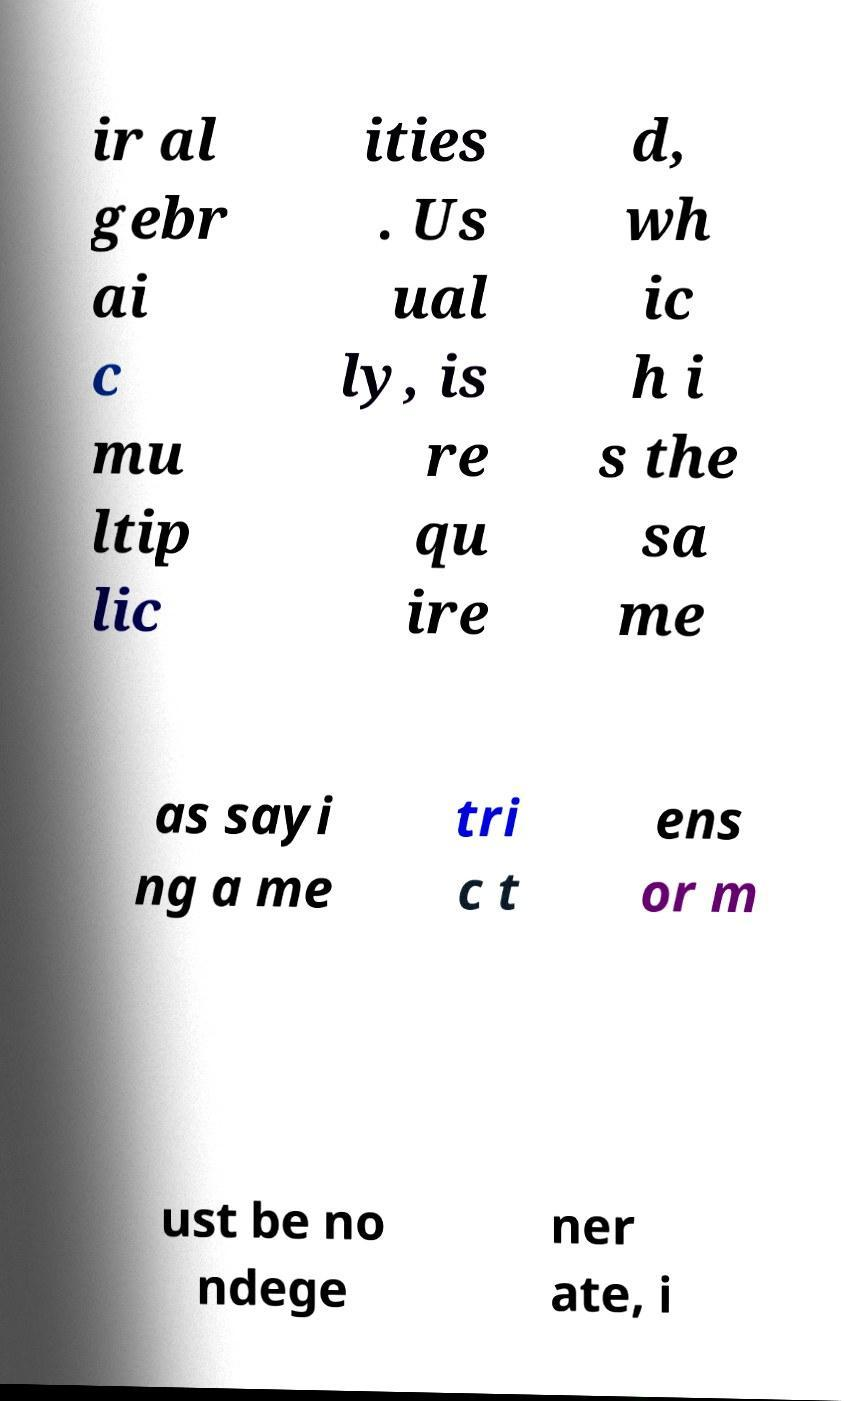Can you read and provide the text displayed in the image?This photo seems to have some interesting text. Can you extract and type it out for me? ir al gebr ai c mu ltip lic ities . Us ual ly, is re qu ire d, wh ic h i s the sa me as sayi ng a me tri c t ens or m ust be no ndege ner ate, i 